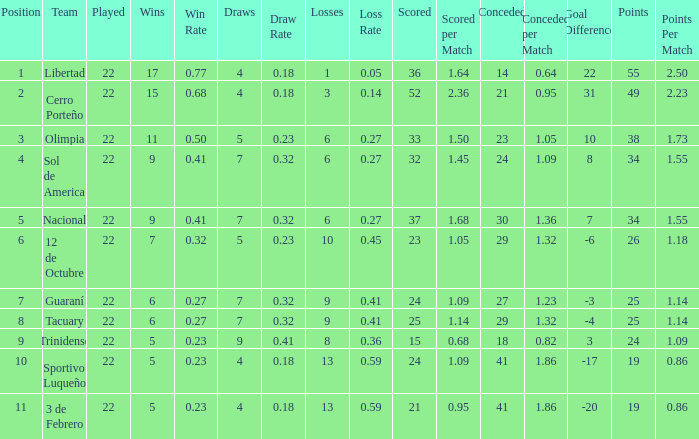What is the value scored when there were 19 points for the team 3 de Febrero? 21.0. 